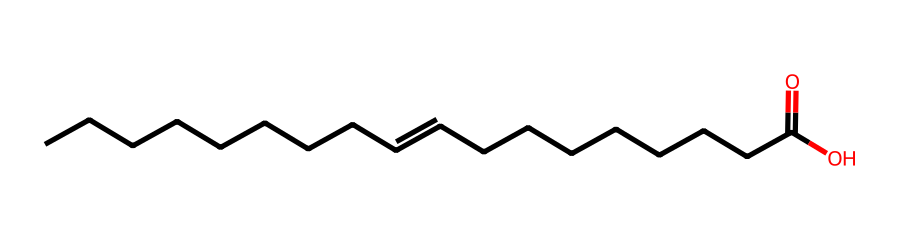What is the chemical name of this compound? The SMILES representation indicates a long-chain fatty acid with a carboxylic acid functional group. Recognizing the pattern of saturated and unsaturated carbon chains, the compound can be named as oleic acid, commonly found in olive oil.
Answer: oleic acid How many carbon atoms are present in oleic acid? Counting the 'C' components in the SMILES representation, including those in the carboxylic acid group, there are 18 carbon atoms total in the molecule.
Answer: 18 What functional group is present in this structure? The SMILES notation shows "C(=O)O" which indicates a carboxylic acid functional group with a carbon double-bonded to oxygen (carbonyl) and single-bonded to hydroxyl (–OH) group.
Answer: carboxylic acid How many double bonds are in oleic acid? The notation includes the "=C" part, demonstrating that there is one double bond present between two carbon atoms in the chain.
Answer: 1 What type of lipid is oleic acid classified as? Given the presence of a long hydrocarbon chain and the carboxylic acid group, oleic acid belongs to the category of unsaturated fatty acids, which are a type of lipid.
Answer: unsaturated fatty acid What is the total number of hydrogen atoms in oleic acid? Each carbon can generally bond to two hydrogen atoms in saturated conditions; however, with one double bond and the carboxylic acid group, the total count is adjusted. Therefore, for oleic acid with 18 carbons, there are 34 hydrogen atoms calculated as (2n + 1 - 2), where n is the number of carbons due to the functional groups.
Answer: 34 